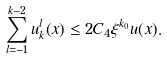Convert formula to latex. <formula><loc_0><loc_0><loc_500><loc_500>\sum ^ { k - 2 } _ { l = - 1 } u ^ { l } _ { k } ( x ) \leq 2 C _ { 4 } \xi ^ { k _ { 0 } } u ( x ) .</formula> 